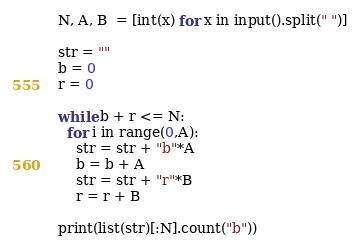<code> <loc_0><loc_0><loc_500><loc_500><_Python_>N, A, B  = [int(x) for x in input().split(" ")]

str = ""
b = 0
r = 0

while b + r <= N:
  for i in range(0,A):
    str = str + "b"*A
    b = b + A
    str = str + "r"*B
    r = r + B

print(list(str)[:N].count("b"))

</code> 